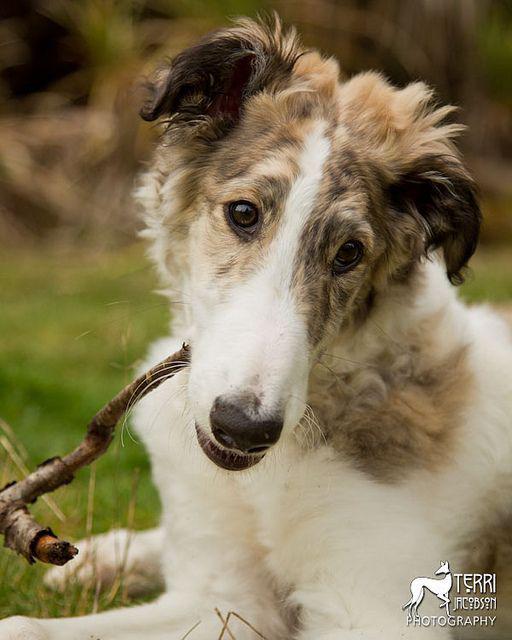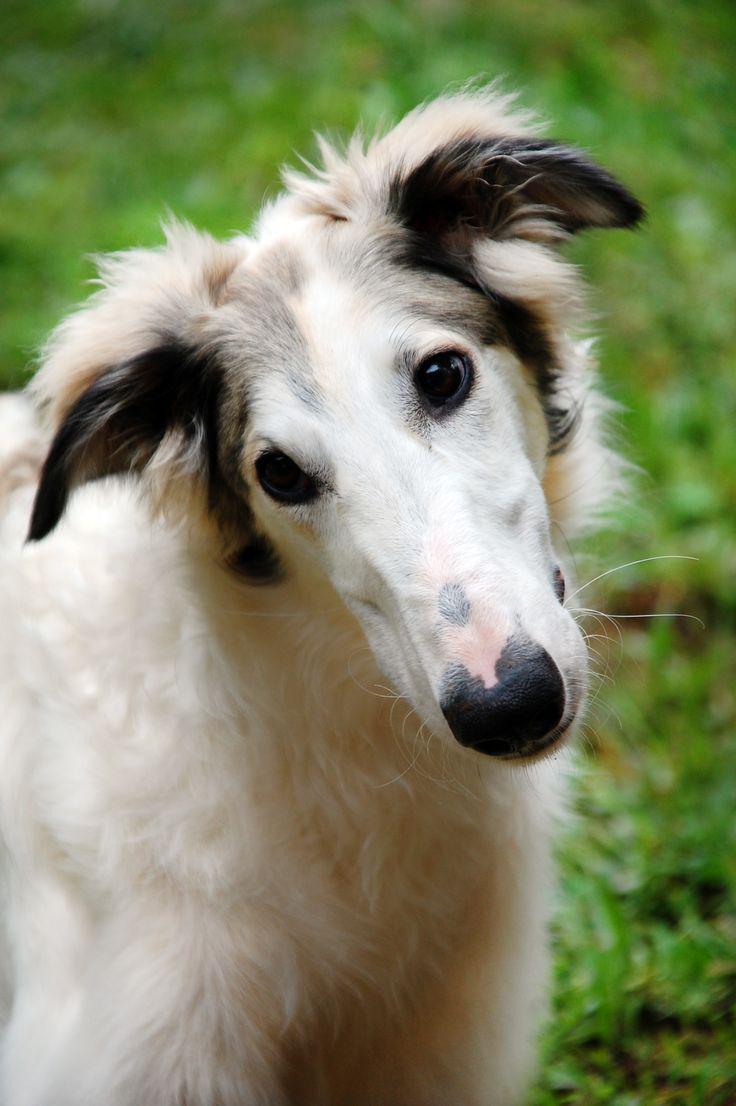The first image is the image on the left, the second image is the image on the right. Considering the images on both sides, is "The left image is a profile with the dog facing right." valid? Answer yes or no. No. 